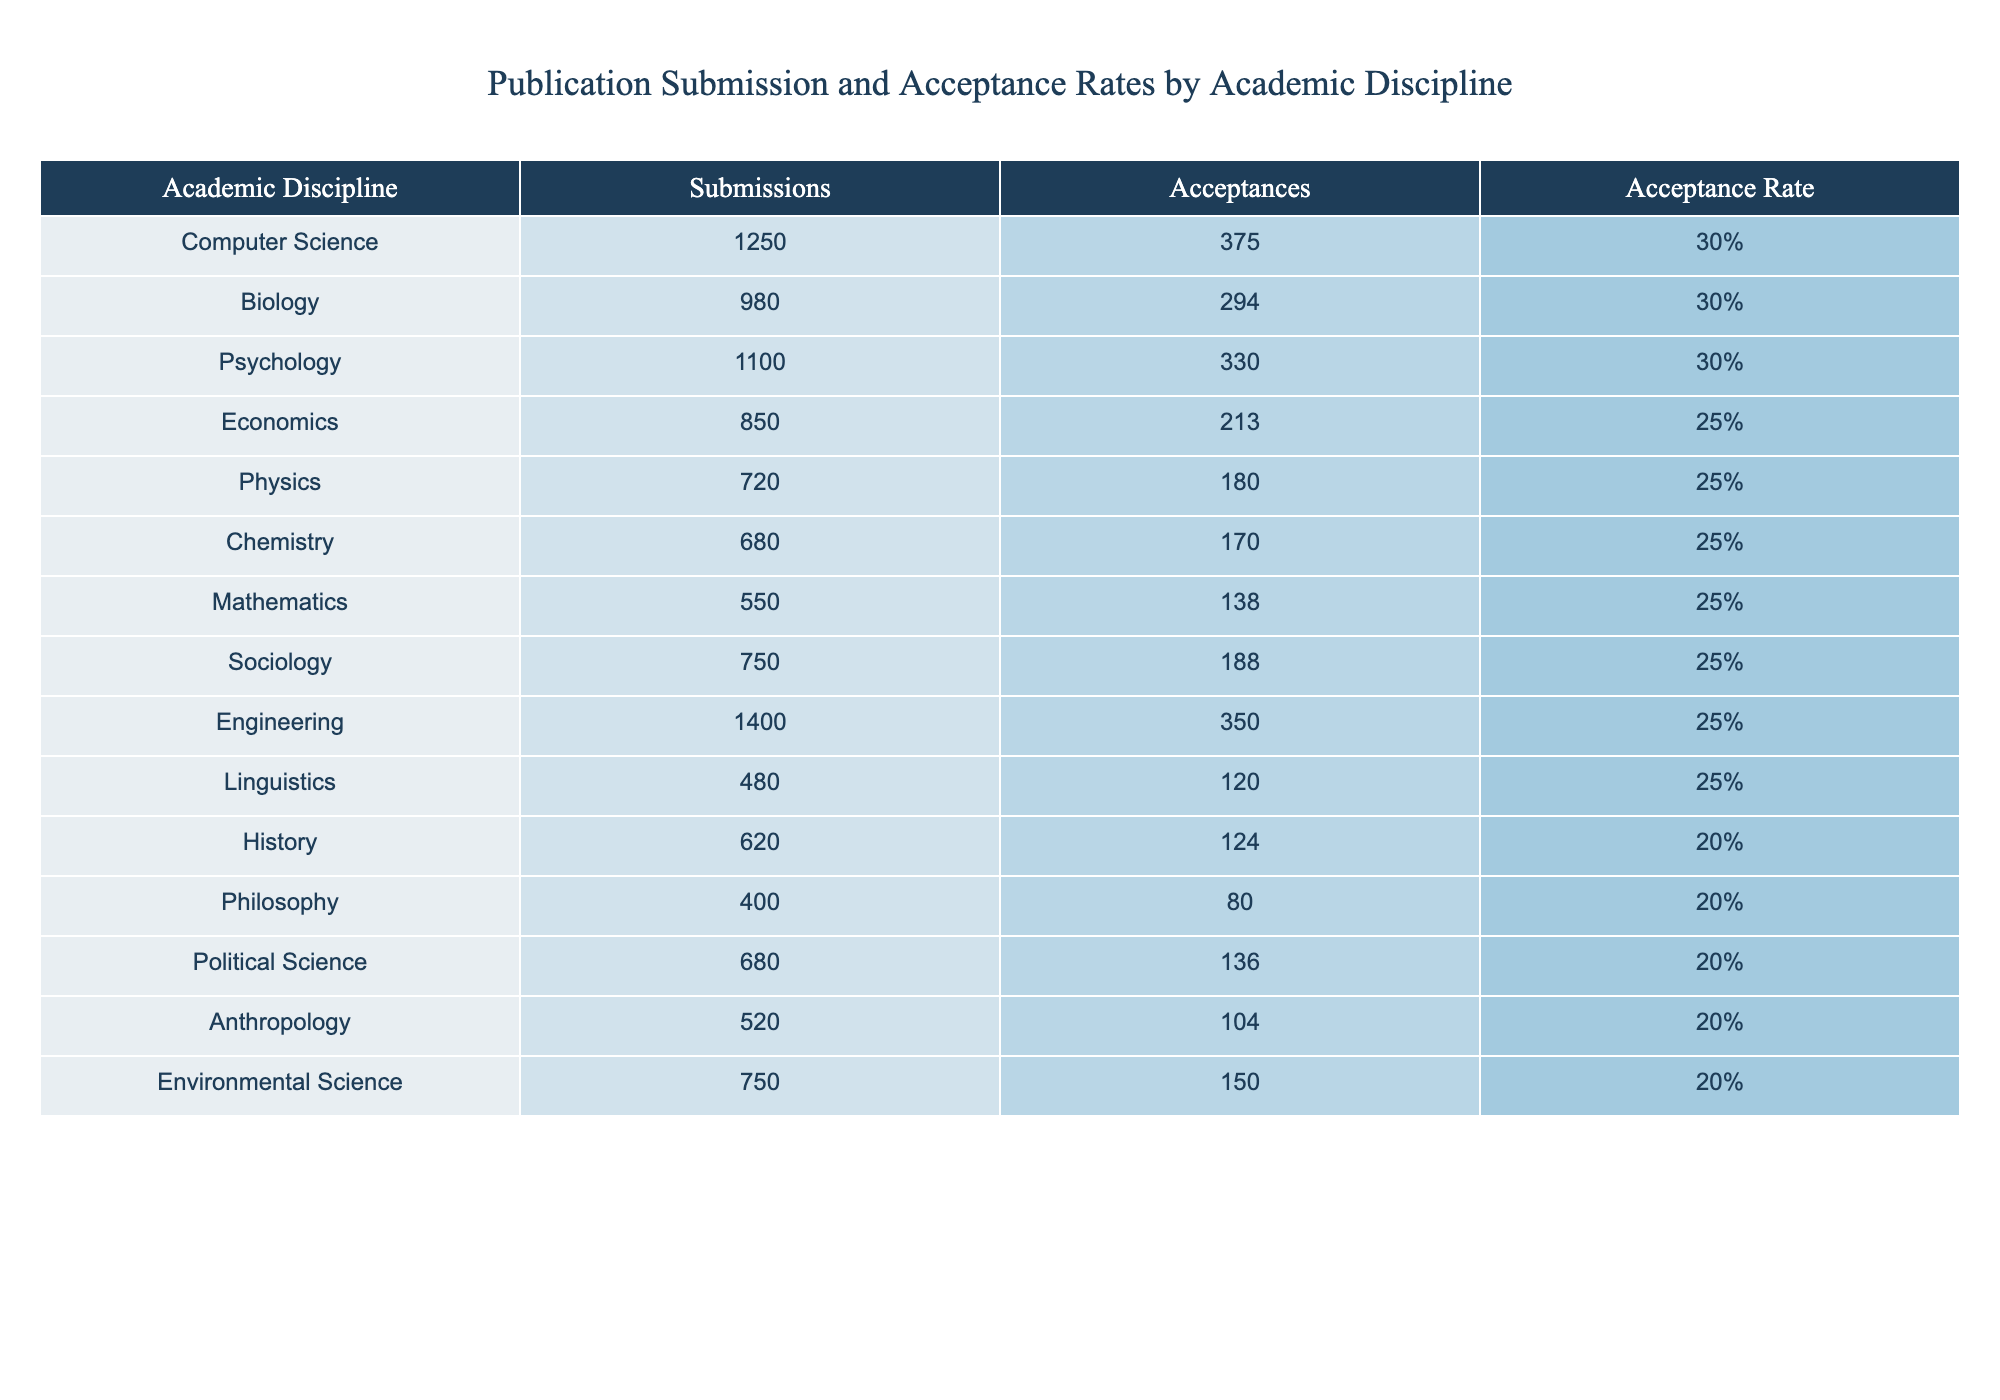What is the acceptance rate for Biology? The acceptance rate for Biology is provided directly in the table under the Acceptance Rate column. It shows that the acceptance rate is 30%.
Answer: 30% Which academic discipline has the highest number of submissions? By checking the Submissions column in the table, we see that Computer Science has the highest number of submissions at 1250.
Answer: Computer Science What is the average acceptance rate for disciplines with at least 1000 submissions? We identify all disciplines with submissions of 1000 or more: Computer Science (30%), Psychology (30%), Biology (30%), and Engineering (25%). We then calculate the average: (30 + 30 + 30 + 25) / 4 = 28.75%.
Answer: 28.75% Is the acceptance rate for Mathematics higher than that for Sociology? The acceptance rate for Mathematics is 25% and for Sociology is also 25%. Since they are equal, the answer is no, Mathematics does not have a higher acceptance rate than Sociology.
Answer: No How many total acceptances were there for the disciplines with a 20% acceptance rate? The disciplines with a 20% acceptance rate are History (124), Philosophy (80), Political Science (136), Anthropology (104), and Environmental Science (150). Adding these acceptances gives: 124 + 80 + 136 + 104 + 150 = 594.
Answer: 594 What is the difference in acceptance rates between Computer Science and Chemistry? From the Acceptance Rate column, Computer Science has an acceptance rate of 30%, and Chemistry has an acceptance rate of 25%. The difference is 30% - 25% = 5%.
Answer: 5% Is the number of acceptances for Psychology greater than the total number of acceptances for both Physics and Chemistry combined? Acceptances for Psychology is 330, and for Physics is 180 and Chemistry is 170. The total for Physics and Chemistry is 180 + 170 = 350. Since 330 is less than 350, the answer is no.
Answer: No How many more submissions does Engineering have compared to Mathematics? Engineering has 1400 submissions and Mathematics has 550. The difference is 1400 - 550 = 850 submissions more for Engineering.
Answer: 850 What percentage of the total submissions does Linguistics represent? The total submissions across all listed disciplines is 1250 + 980 + 1100 + 850 + 720 + 680 + 550 + 750 + 1400 + 480 + 620 + 400 + 680 + 520 + 750 = 11380. Linguistics has 480 submissions. The percentage is (480 / 11380) * 100 = 4.21%.
Answer: 4.21% Which discipline has the least number of acceptances, and what is the acceptance rate? From the Acceptance column, we identify that Philosophy has the least acceptances with 80, and the acceptance rate for Philosophy is 20%.
Answer: Philosophy, 20% 